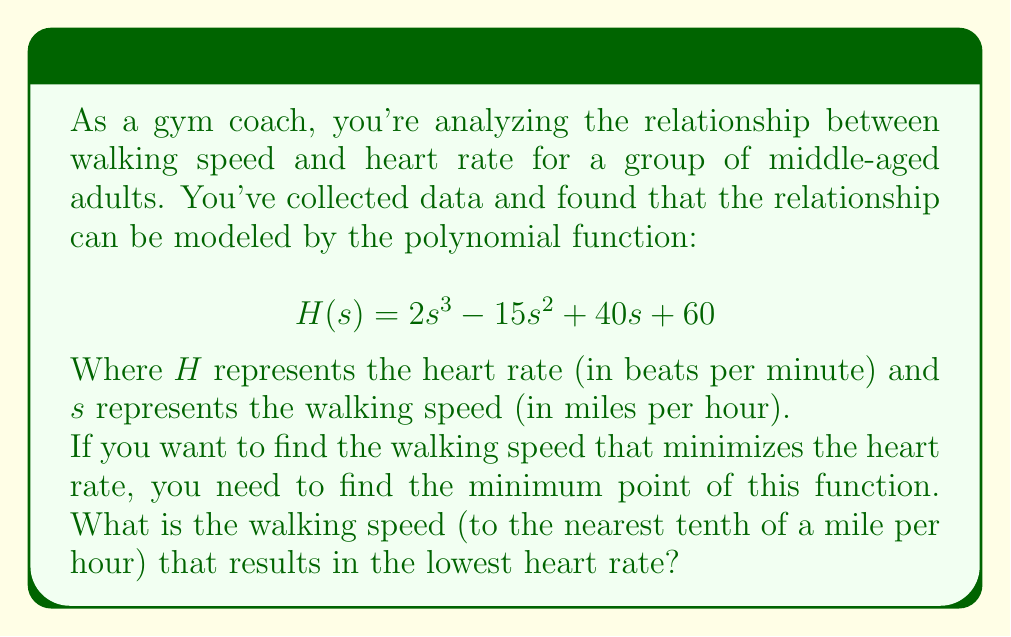What is the answer to this math problem? To find the walking speed that minimizes the heart rate, we need to follow these steps:

1) First, we need to find the derivative of the function $H(s)$:
   $$H'(s) = 6s^2 - 30s + 40$$

2) To find the minimum point, we set the derivative equal to zero and solve for $s$:
   $$6s^2 - 30s + 40 = 0$$

3) This is a quadratic equation. We can solve it using the quadratic formula:
   $$s = \frac{-b \pm \sqrt{b^2 - 4ac}}{2a}$$
   Where $a = 6$, $b = -30$, and $c = 40$

4) Plugging in these values:
   $$s = \frac{30 \pm \sqrt{(-30)^2 - 4(6)(40)}}{2(6)}$$
   $$s = \frac{30 \pm \sqrt{900 - 960}}{12}$$
   $$s = \frac{30 \pm \sqrt{-60}}{12}$$

5) Since we're dealing with real walking speeds, we can discard the imaginary solutions. The real solution is:
   $$s = \frac{30}{12} = 2.5$$

6) To confirm this is a minimum (not a maximum), we can check the second derivative:
   $$H''(s) = 12s - 30$$
   At $s = 2.5$: $H''(2.5) = 12(2.5) - 30 = 0$
   This is an inflection point, so we need to check values on either side:
   At $s = 2$: $H''(2) = 12(2) - 30 = -6$ (negative)
   At $s = 3$: $H''(3) = 12(3) - 30 = 6$ (positive)
   This confirms that $s = 2.5$ is indeed a minimum.

Therefore, the walking speed that minimizes heart rate is 2.5 miles per hour.
Answer: 2.5 miles per hour 